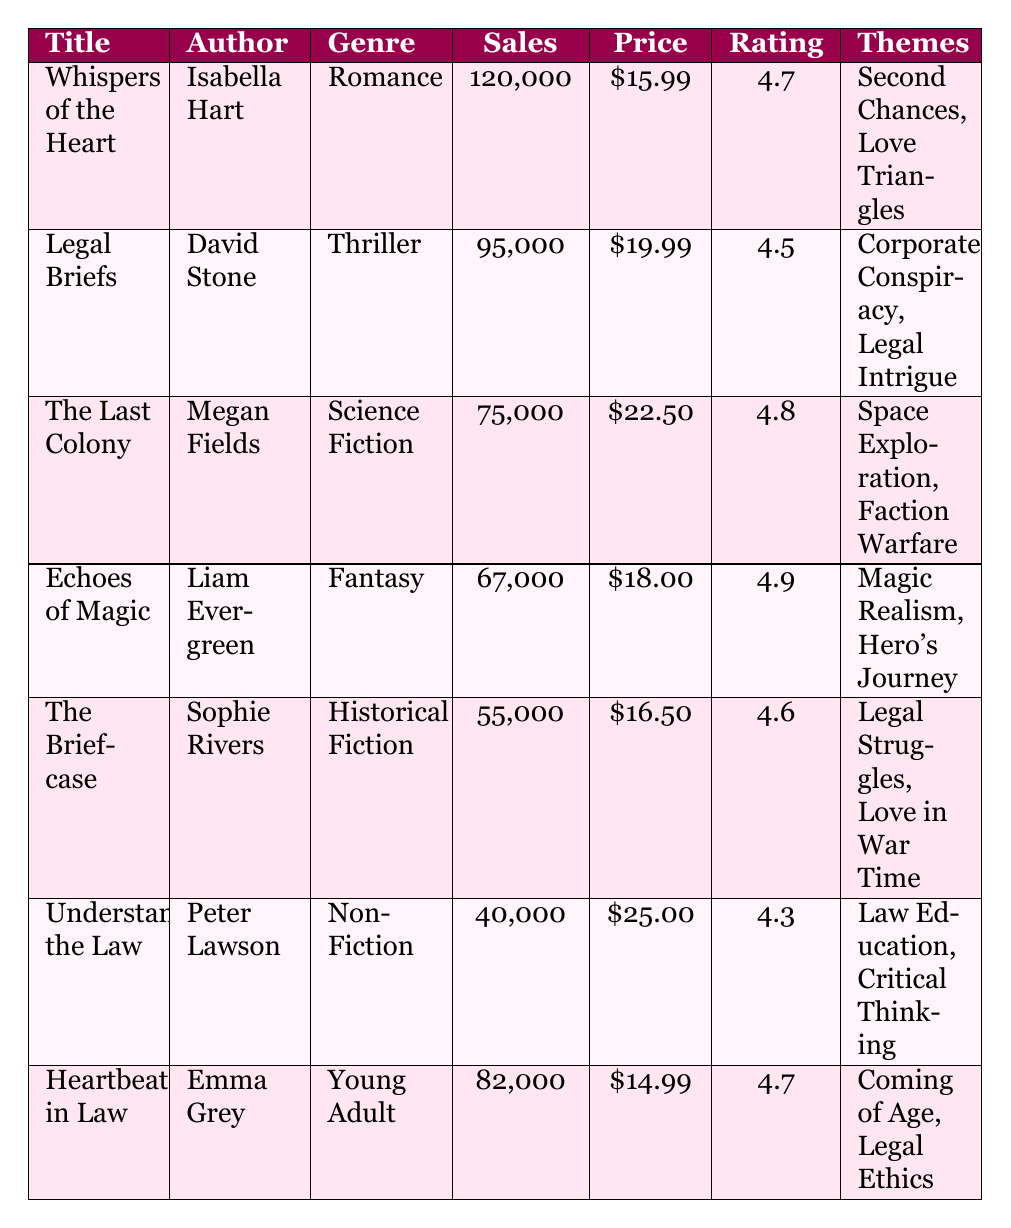What is the highest selling book in the Romance genre? The Romance genre has "Whispers of the Heart" with 120,000 sales units, which is the highest among all listed Romance books in the table.
Answer: Whispers of the Heart Which book has the lowest average price? In the table, "Heartbeats in Law" is priced at $14.99, which is the lowest average price among all the books.
Answer: Heartbeats in Law How many more sales units did "Whispers of the Heart" have compared to "Understanding the Law"? "Whispers of the Heart" sold 120,000 units, and "Understanding the Law" sold 40,000 units. The difference is 120,000 - 40,000 = 80,000 sales units.
Answer: 80,000 Is "The Briefcase" a Historical Fiction book? According to the table, "The Briefcase" is categorized under Historical Fiction, confirming that it is indeed a Historical Fiction book.
Answer: Yes Calculate the average rating of all books in the table. The ratings are 4.7, 4.5, 4.8, 4.9, 4.6, 4.3, and 4.7. The sum of ratings is 4.7 + 4.5 + 4.8 + 4.9 + 4.6 + 4.3 + 4.7 = 29.5. There are 7 books, so the average rating is 29.5 / 7 = 4.21.
Answer: 4.21 Which genre has the highest number of awards won? The Romance genre has "Whispers of the Heart," which won 1 award. The Fantasy genre has "Echoes of Magic," which also won 1 award. Although both genres won equal awards, Romance is notable for featuring legal themes.
Answer: Romance What is the total sales units of the Fantasy and Historical Fiction genres combined? "Echoes of Magic" (Fantasy) sold 67,000 units and "The Briefcase" (Historical Fiction) sold 55,000 units, totaling 67,000 + 55,000 = 122,000 units.
Answer: 122,000 Does "Understanding the Law" have any awards? The table states that "Understanding the Law" does not have any awards listed, indicating that it has no awards.
Answer: No What themes are featured in "Heartbeats in Law"? The themes for "Heartbeats in Law" are listed as "Coming of Age" and "Legal Ethics," both of which are stated in the table.
Answer: Coming of Age, Legal Ethics How does the average price of Romance books compare to Thriller books? The average price for Romance books (Whispers of the Heart) is $15.99. The Thriller book (Legal Briefs) has an average price of $19.99. To compare, $15.99 is less than $19.99, showing that Romance books are cheaper on average.
Answer: Romance books are cheaper 